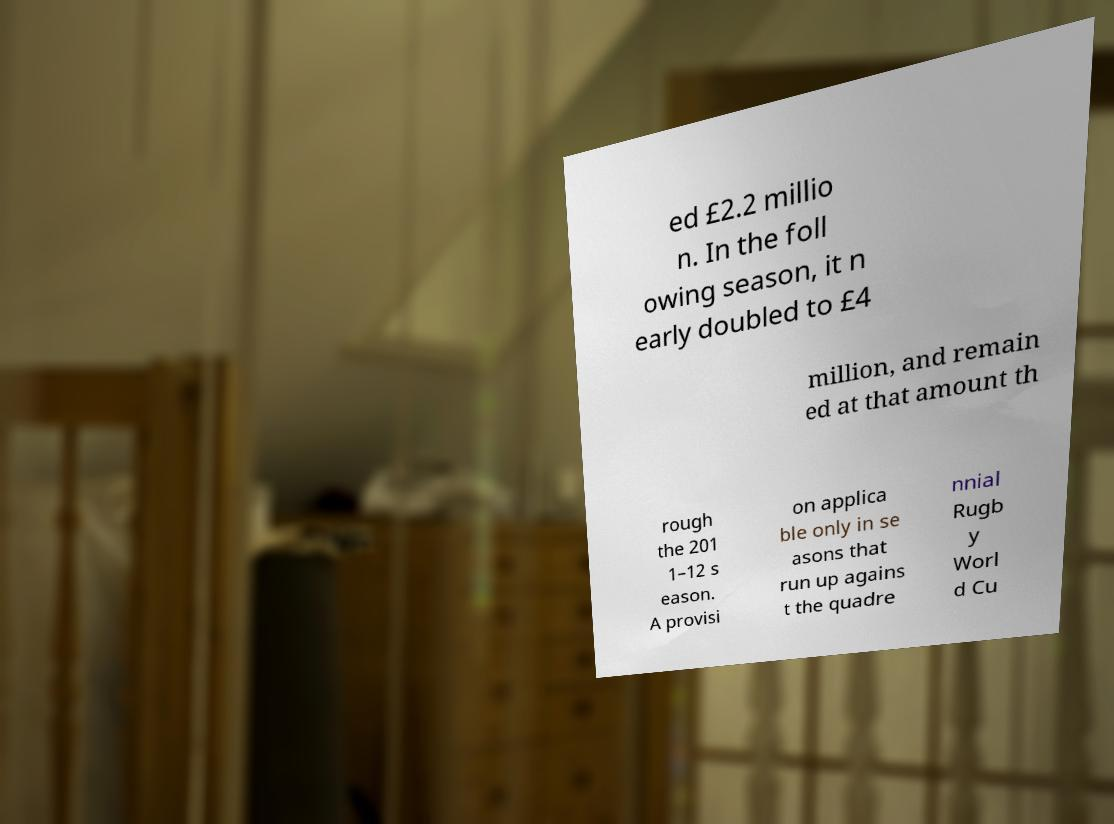For documentation purposes, I need the text within this image transcribed. Could you provide that? ed £2.2 millio n. In the foll owing season, it n early doubled to £4 million, and remain ed at that amount th rough the 201 1–12 s eason. A provisi on applica ble only in se asons that run up agains t the quadre nnial Rugb y Worl d Cu 